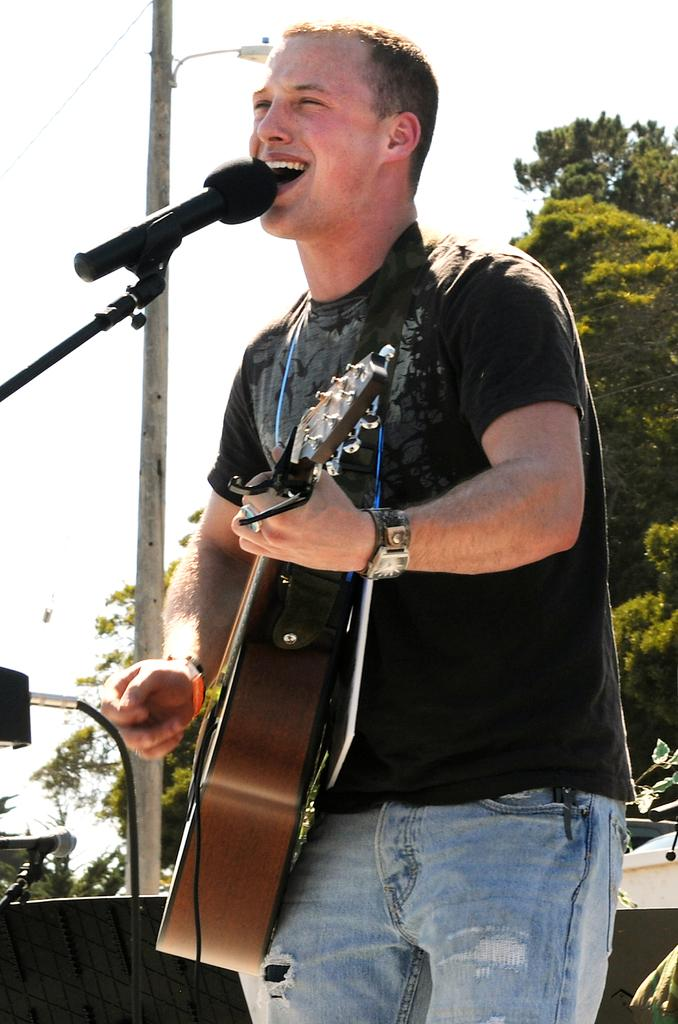Who is the main subject in the image? There is a man in the image. Where is the man positioned in the image? The man is standing in the center of the image. What is the man holding in the image? The man is holding a musical instrument. What is the man doing with the microphone in the image? The man is singing in front of a microphone. What can be seen in the background of the image? There are trees, an electrical pole, and the sky visible in the background of the image. What type of shirt is the man wearing in the image? The provided facts do not mention the type of shirt the man is wearing. Where is the drawer located in the image? There is no drawer present in the image. 